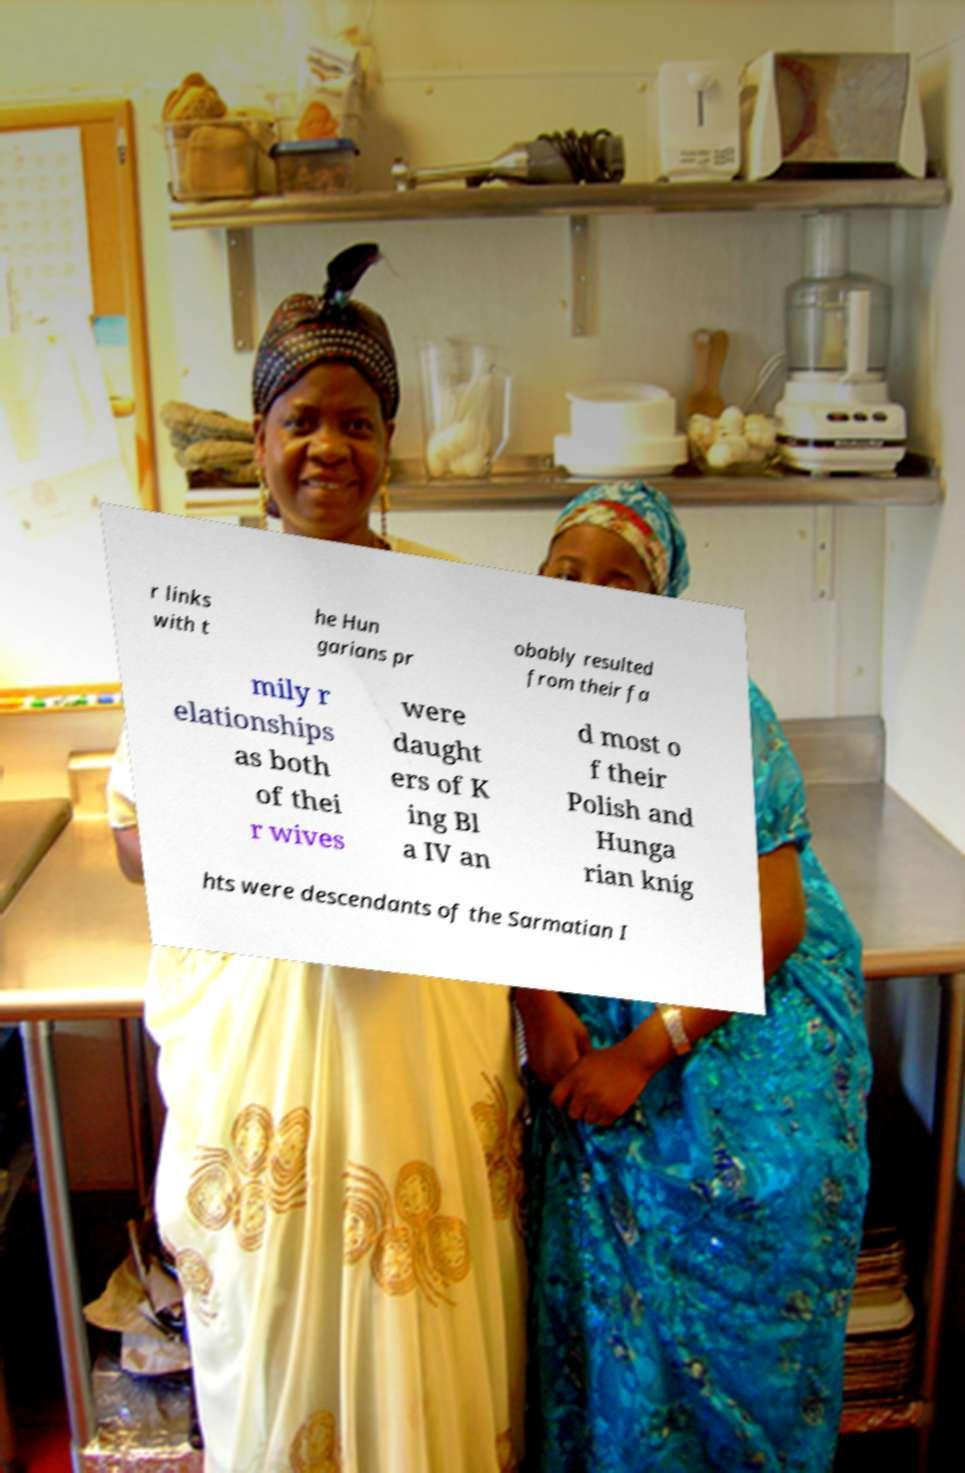Can you read and provide the text displayed in the image?This photo seems to have some interesting text. Can you extract and type it out for me? r links with t he Hun garians pr obably resulted from their fa mily r elationships as both of thei r wives were daught ers of K ing Bl a IV an d most o f their Polish and Hunga rian knig hts were descendants of the Sarmatian I 